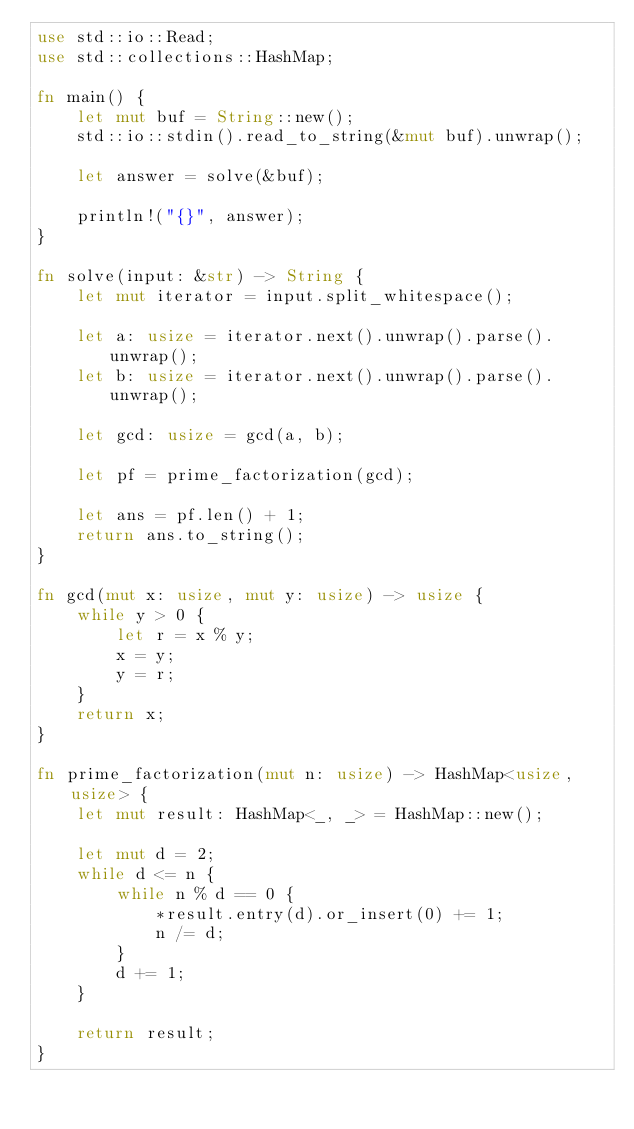<code> <loc_0><loc_0><loc_500><loc_500><_Rust_>use std::io::Read;
use std::collections::HashMap;

fn main() {
    let mut buf = String::new();
    std::io::stdin().read_to_string(&mut buf).unwrap();

    let answer = solve(&buf);

    println!("{}", answer);
}

fn solve(input: &str) -> String {
    let mut iterator = input.split_whitespace();

    let a: usize = iterator.next().unwrap().parse().unwrap();
    let b: usize = iterator.next().unwrap().parse().unwrap();

    let gcd: usize = gcd(a, b);

    let pf = prime_factorization(gcd);

    let ans = pf.len() + 1;
    return ans.to_string();
}

fn gcd(mut x: usize, mut y: usize) -> usize {
    while y > 0 {
        let r = x % y;
        x = y;
        y = r;
    }
    return x;
}

fn prime_factorization(mut n: usize) -> HashMap<usize, usize> {
    let mut result: HashMap<_, _> = HashMap::new();

    let mut d = 2;
    while d <= n {
        while n % d == 0 {
            *result.entry(d).or_insert(0) += 1;
            n /= d;
        }
        d += 1;
    }

    return result;
}
</code> 